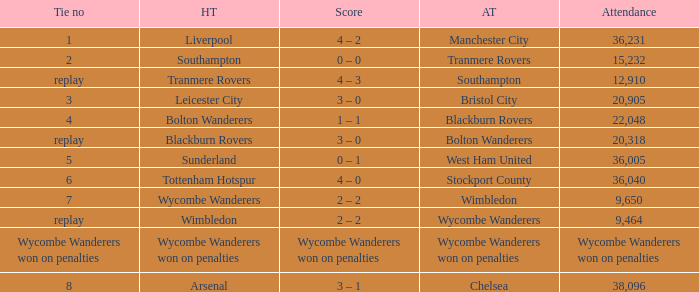What was the attendance for the game where the away team was Stockport County? 36040.0. 